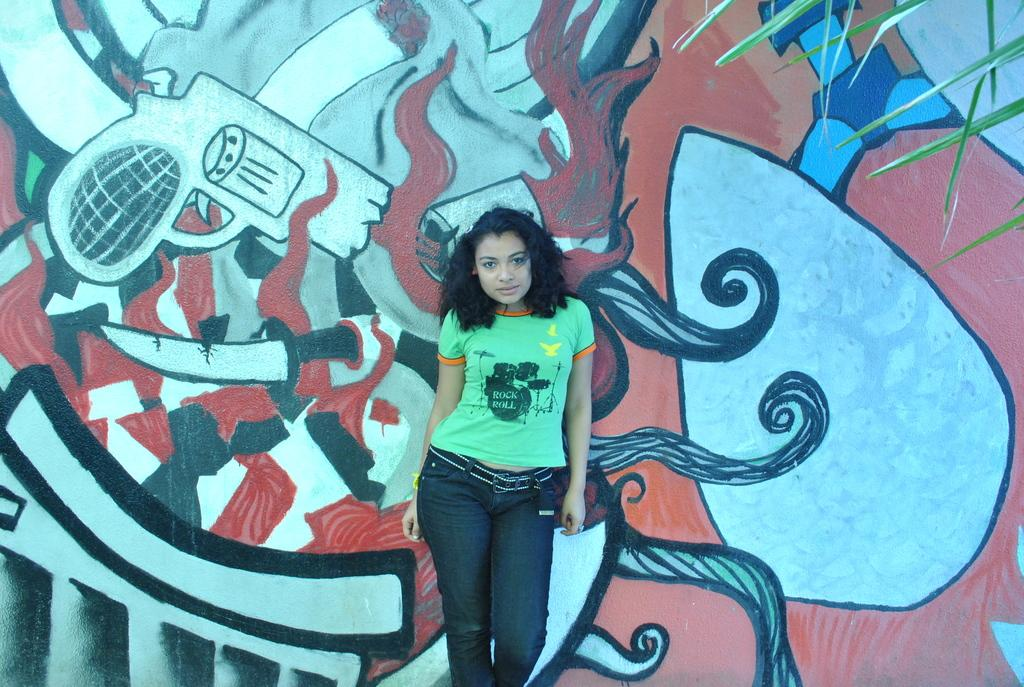What is there is a lady standing in the center of the image, can you describe her? There is a lady standing in the center of the image, but no specific details about her appearance are provided. What is on the wall in the background of the image? There is a painting on the wall in the background of the image. What can be seen in the background of the image besides the painting? There is a tree visible in the background of the image. How many fingers does the lady have on her right hand in the image? There is no information provided about the lady's fingers or her right hand in the image. 